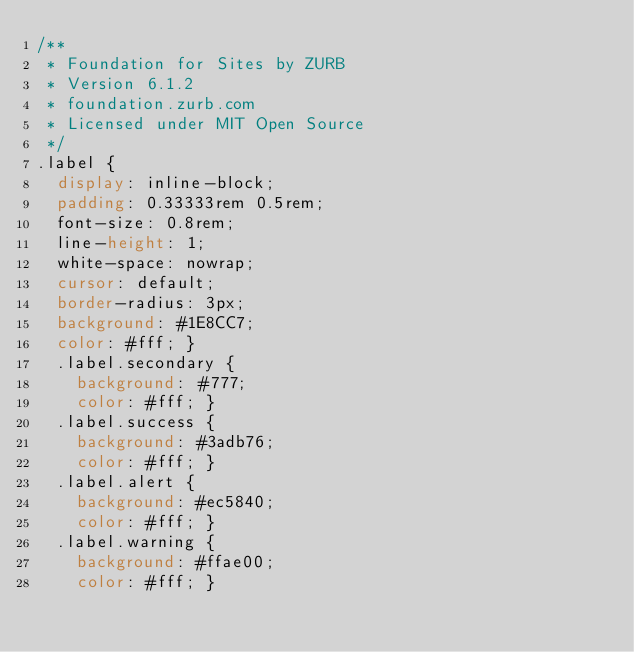Convert code to text. <code><loc_0><loc_0><loc_500><loc_500><_CSS_>/**
 * Foundation for Sites by ZURB
 * Version 6.1.2
 * foundation.zurb.com
 * Licensed under MIT Open Source
 */
.label {
  display: inline-block;
  padding: 0.33333rem 0.5rem;
  font-size: 0.8rem;
  line-height: 1;
  white-space: nowrap;
  cursor: default;
  border-radius: 3px;
  background: #1E8CC7;
  color: #fff; }
  .label.secondary {
    background: #777;
    color: #fff; }
  .label.success {
    background: #3adb76;
    color: #fff; }
  .label.alert {
    background: #ec5840;
    color: #fff; }
  .label.warning {
    background: #ffae00;
    color: #fff; }
</code> 